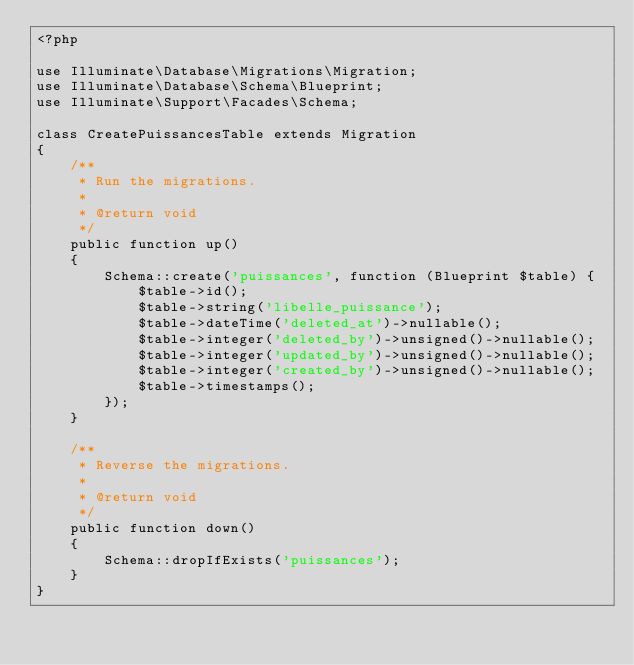<code> <loc_0><loc_0><loc_500><loc_500><_PHP_><?php

use Illuminate\Database\Migrations\Migration;
use Illuminate\Database\Schema\Blueprint;
use Illuminate\Support\Facades\Schema;

class CreatePuissancesTable extends Migration
{
    /**
     * Run the migrations.
     *
     * @return void
     */
    public function up()
    {
        Schema::create('puissances', function (Blueprint $table) {
            $table->id();
            $table->string('libelle_puissance');
            $table->dateTime('deleted_at')->nullable();
            $table->integer('deleted_by')->unsigned()->nullable();
            $table->integer('updated_by')->unsigned()->nullable();
            $table->integer('created_by')->unsigned()->nullable();
            $table->timestamps();
        });
    }

    /**
     * Reverse the migrations.
     *
     * @return void
     */
    public function down()
    {
        Schema::dropIfExists('puissances');
    }
}
</code> 